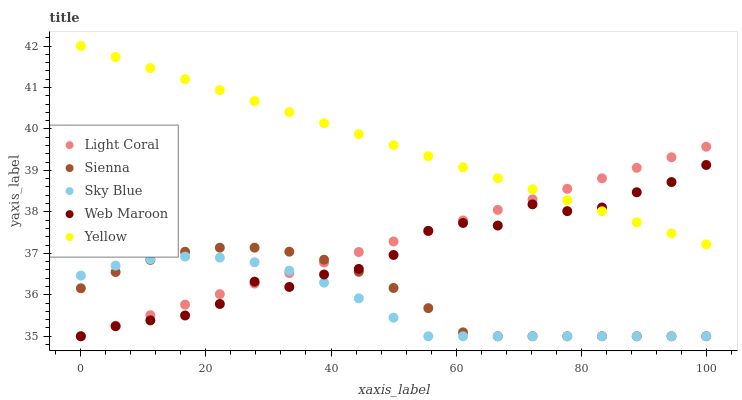Does Sky Blue have the minimum area under the curve?
Answer yes or no. Yes. Does Yellow have the maximum area under the curve?
Answer yes or no. Yes. Does Sienna have the minimum area under the curve?
Answer yes or no. No. Does Sienna have the maximum area under the curve?
Answer yes or no. No. Is Light Coral the smoothest?
Answer yes or no. Yes. Is Web Maroon the roughest?
Answer yes or no. Yes. Is Sienna the smoothest?
Answer yes or no. No. Is Sienna the roughest?
Answer yes or no. No. Does Light Coral have the lowest value?
Answer yes or no. Yes. Does Yellow have the lowest value?
Answer yes or no. No. Does Yellow have the highest value?
Answer yes or no. Yes. Does Sienna have the highest value?
Answer yes or no. No. Is Sky Blue less than Yellow?
Answer yes or no. Yes. Is Yellow greater than Sky Blue?
Answer yes or no. Yes. Does Light Coral intersect Web Maroon?
Answer yes or no. Yes. Is Light Coral less than Web Maroon?
Answer yes or no. No. Is Light Coral greater than Web Maroon?
Answer yes or no. No. Does Sky Blue intersect Yellow?
Answer yes or no. No. 